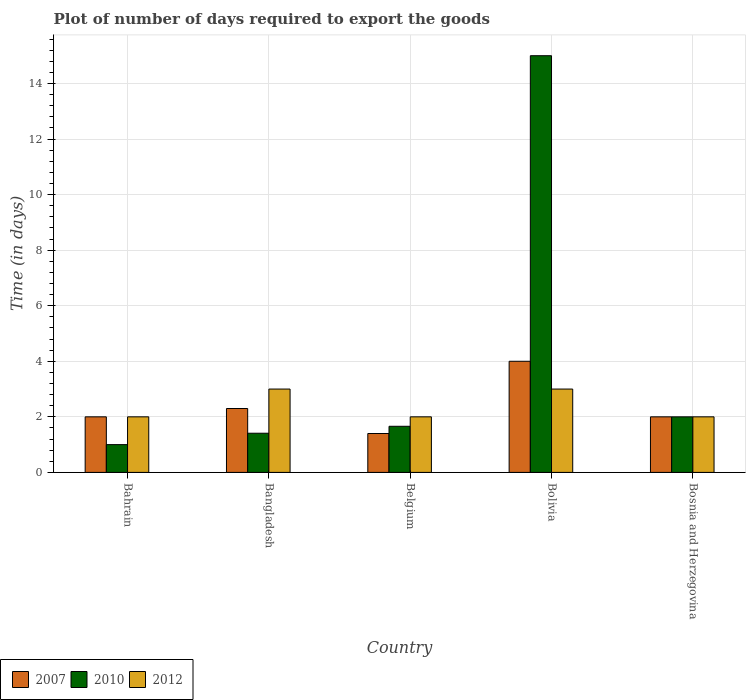How many different coloured bars are there?
Your answer should be compact. 3. How many groups of bars are there?
Your answer should be very brief. 5. Are the number of bars per tick equal to the number of legend labels?
Provide a short and direct response. Yes. Are the number of bars on each tick of the X-axis equal?
Offer a terse response. Yes. How many bars are there on the 4th tick from the right?
Give a very brief answer. 3. In how many cases, is the number of bars for a given country not equal to the number of legend labels?
Your response must be concise. 0. Across all countries, what is the minimum time required to export goods in 2010?
Ensure brevity in your answer.  1. In which country was the time required to export goods in 2012 maximum?
Your response must be concise. Bangladesh. In which country was the time required to export goods in 2010 minimum?
Make the answer very short. Bahrain. What is the total time required to export goods in 2010 in the graph?
Your answer should be compact. 21.07. What is the difference between the time required to export goods in 2012 in Bangladesh and the time required to export goods in 2010 in Bosnia and Herzegovina?
Offer a very short reply. 1. What is the average time required to export goods in 2007 per country?
Your answer should be very brief. 2.34. What is the difference between the time required to export goods of/in 2010 and time required to export goods of/in 2007 in Bangladesh?
Your answer should be compact. -0.89. In how many countries, is the time required to export goods in 2010 greater than 2.4 days?
Ensure brevity in your answer.  1. What is the ratio of the time required to export goods in 2010 in Belgium to that in Bosnia and Herzegovina?
Provide a succinct answer. 0.83. Is the time required to export goods in 2012 in Bahrain less than that in Bangladesh?
Provide a short and direct response. Yes. What is the difference between the highest and the second highest time required to export goods in 2007?
Offer a very short reply. 0.3. What is the difference between the highest and the lowest time required to export goods in 2012?
Make the answer very short. 1. In how many countries, is the time required to export goods in 2012 greater than the average time required to export goods in 2012 taken over all countries?
Your answer should be very brief. 2. Is the sum of the time required to export goods in 2007 in Bahrain and Bolivia greater than the maximum time required to export goods in 2010 across all countries?
Your answer should be compact. No. Are the values on the major ticks of Y-axis written in scientific E-notation?
Keep it short and to the point. No. Does the graph contain grids?
Keep it short and to the point. Yes. How are the legend labels stacked?
Offer a very short reply. Horizontal. What is the title of the graph?
Make the answer very short. Plot of number of days required to export the goods. What is the label or title of the Y-axis?
Give a very brief answer. Time (in days). What is the Time (in days) in 2010 in Bahrain?
Offer a terse response. 1. What is the Time (in days) of 2010 in Bangladesh?
Make the answer very short. 1.41. What is the Time (in days) in 2007 in Belgium?
Offer a very short reply. 1.4. What is the Time (in days) of 2010 in Belgium?
Offer a terse response. 1.66. What is the Time (in days) in 2010 in Bolivia?
Give a very brief answer. 15. What is the Time (in days) in 2007 in Bosnia and Herzegovina?
Give a very brief answer. 2. What is the Time (in days) of 2010 in Bosnia and Herzegovina?
Provide a short and direct response. 2. Across all countries, what is the maximum Time (in days) of 2007?
Keep it short and to the point. 4. What is the total Time (in days) in 2007 in the graph?
Your answer should be very brief. 11.7. What is the total Time (in days) in 2010 in the graph?
Your answer should be very brief. 21.07. What is the difference between the Time (in days) of 2007 in Bahrain and that in Bangladesh?
Ensure brevity in your answer.  -0.3. What is the difference between the Time (in days) in 2010 in Bahrain and that in Bangladesh?
Keep it short and to the point. -0.41. What is the difference between the Time (in days) of 2012 in Bahrain and that in Bangladesh?
Provide a succinct answer. -1. What is the difference between the Time (in days) of 2010 in Bahrain and that in Belgium?
Ensure brevity in your answer.  -0.66. What is the difference between the Time (in days) of 2007 in Bahrain and that in Bolivia?
Your answer should be compact. -2. What is the difference between the Time (in days) of 2010 in Bahrain and that in Bolivia?
Your answer should be very brief. -14. What is the difference between the Time (in days) of 2012 in Bahrain and that in Bolivia?
Keep it short and to the point. -1. What is the difference between the Time (in days) of 2007 in Bahrain and that in Bosnia and Herzegovina?
Keep it short and to the point. 0. What is the difference between the Time (in days) of 2010 in Bangladesh and that in Belgium?
Your answer should be very brief. -0.25. What is the difference between the Time (in days) of 2012 in Bangladesh and that in Belgium?
Make the answer very short. 1. What is the difference between the Time (in days) in 2007 in Bangladesh and that in Bolivia?
Your response must be concise. -1.7. What is the difference between the Time (in days) of 2010 in Bangladesh and that in Bolivia?
Your answer should be very brief. -13.59. What is the difference between the Time (in days) in 2010 in Bangladesh and that in Bosnia and Herzegovina?
Make the answer very short. -0.59. What is the difference between the Time (in days) in 2012 in Bangladesh and that in Bosnia and Herzegovina?
Offer a very short reply. 1. What is the difference between the Time (in days) in 2010 in Belgium and that in Bolivia?
Your answer should be very brief. -13.34. What is the difference between the Time (in days) in 2010 in Belgium and that in Bosnia and Herzegovina?
Provide a succinct answer. -0.34. What is the difference between the Time (in days) of 2007 in Bolivia and that in Bosnia and Herzegovina?
Provide a succinct answer. 2. What is the difference between the Time (in days) of 2007 in Bahrain and the Time (in days) of 2010 in Bangladesh?
Keep it short and to the point. 0.59. What is the difference between the Time (in days) in 2007 in Bahrain and the Time (in days) in 2012 in Bangladesh?
Ensure brevity in your answer.  -1. What is the difference between the Time (in days) of 2007 in Bahrain and the Time (in days) of 2010 in Belgium?
Ensure brevity in your answer.  0.34. What is the difference between the Time (in days) in 2010 in Bahrain and the Time (in days) in 2012 in Belgium?
Your answer should be very brief. -1. What is the difference between the Time (in days) of 2010 in Bahrain and the Time (in days) of 2012 in Bolivia?
Offer a very short reply. -2. What is the difference between the Time (in days) in 2007 in Bahrain and the Time (in days) in 2010 in Bosnia and Herzegovina?
Provide a succinct answer. 0. What is the difference between the Time (in days) of 2007 in Bangladesh and the Time (in days) of 2010 in Belgium?
Your answer should be very brief. 0.64. What is the difference between the Time (in days) in 2007 in Bangladesh and the Time (in days) in 2012 in Belgium?
Make the answer very short. 0.3. What is the difference between the Time (in days) of 2010 in Bangladesh and the Time (in days) of 2012 in Belgium?
Provide a short and direct response. -0.59. What is the difference between the Time (in days) of 2007 in Bangladesh and the Time (in days) of 2012 in Bolivia?
Ensure brevity in your answer.  -0.7. What is the difference between the Time (in days) in 2010 in Bangladesh and the Time (in days) in 2012 in Bolivia?
Offer a very short reply. -1.59. What is the difference between the Time (in days) of 2007 in Bangladesh and the Time (in days) of 2010 in Bosnia and Herzegovina?
Your answer should be compact. 0.3. What is the difference between the Time (in days) in 2010 in Bangladesh and the Time (in days) in 2012 in Bosnia and Herzegovina?
Offer a very short reply. -0.59. What is the difference between the Time (in days) of 2010 in Belgium and the Time (in days) of 2012 in Bolivia?
Offer a terse response. -1.34. What is the difference between the Time (in days) of 2007 in Belgium and the Time (in days) of 2010 in Bosnia and Herzegovina?
Provide a short and direct response. -0.6. What is the difference between the Time (in days) in 2010 in Belgium and the Time (in days) in 2012 in Bosnia and Herzegovina?
Your answer should be very brief. -0.34. What is the difference between the Time (in days) in 2010 in Bolivia and the Time (in days) in 2012 in Bosnia and Herzegovina?
Keep it short and to the point. 13. What is the average Time (in days) in 2007 per country?
Provide a short and direct response. 2.34. What is the average Time (in days) of 2010 per country?
Your response must be concise. 4.21. What is the average Time (in days) of 2012 per country?
Give a very brief answer. 2.4. What is the difference between the Time (in days) of 2007 and Time (in days) of 2012 in Bahrain?
Keep it short and to the point. 0. What is the difference between the Time (in days) in 2010 and Time (in days) in 2012 in Bahrain?
Give a very brief answer. -1. What is the difference between the Time (in days) of 2007 and Time (in days) of 2010 in Bangladesh?
Make the answer very short. 0.89. What is the difference between the Time (in days) of 2007 and Time (in days) of 2012 in Bangladesh?
Provide a succinct answer. -0.7. What is the difference between the Time (in days) in 2010 and Time (in days) in 2012 in Bangladesh?
Provide a succinct answer. -1.59. What is the difference between the Time (in days) in 2007 and Time (in days) in 2010 in Belgium?
Offer a very short reply. -0.26. What is the difference between the Time (in days) in 2007 and Time (in days) in 2012 in Belgium?
Ensure brevity in your answer.  -0.6. What is the difference between the Time (in days) of 2010 and Time (in days) of 2012 in Belgium?
Your answer should be very brief. -0.34. What is the difference between the Time (in days) of 2007 and Time (in days) of 2010 in Bolivia?
Your answer should be very brief. -11. What is the difference between the Time (in days) in 2007 and Time (in days) in 2012 in Bolivia?
Keep it short and to the point. 1. What is the difference between the Time (in days) in 2007 and Time (in days) in 2012 in Bosnia and Herzegovina?
Make the answer very short. 0. What is the difference between the Time (in days) of 2010 and Time (in days) of 2012 in Bosnia and Herzegovina?
Give a very brief answer. 0. What is the ratio of the Time (in days) in 2007 in Bahrain to that in Bangladesh?
Your answer should be compact. 0.87. What is the ratio of the Time (in days) in 2010 in Bahrain to that in Bangladesh?
Your answer should be very brief. 0.71. What is the ratio of the Time (in days) of 2007 in Bahrain to that in Belgium?
Your answer should be very brief. 1.43. What is the ratio of the Time (in days) in 2010 in Bahrain to that in Belgium?
Provide a short and direct response. 0.6. What is the ratio of the Time (in days) of 2012 in Bahrain to that in Belgium?
Offer a very short reply. 1. What is the ratio of the Time (in days) of 2010 in Bahrain to that in Bolivia?
Offer a terse response. 0.07. What is the ratio of the Time (in days) of 2012 in Bahrain to that in Bolivia?
Give a very brief answer. 0.67. What is the ratio of the Time (in days) in 2007 in Bangladesh to that in Belgium?
Ensure brevity in your answer.  1.64. What is the ratio of the Time (in days) in 2010 in Bangladesh to that in Belgium?
Keep it short and to the point. 0.85. What is the ratio of the Time (in days) of 2012 in Bangladesh to that in Belgium?
Make the answer very short. 1.5. What is the ratio of the Time (in days) in 2007 in Bangladesh to that in Bolivia?
Provide a succinct answer. 0.57. What is the ratio of the Time (in days) of 2010 in Bangladesh to that in Bolivia?
Offer a very short reply. 0.09. What is the ratio of the Time (in days) in 2012 in Bangladesh to that in Bolivia?
Your answer should be compact. 1. What is the ratio of the Time (in days) of 2007 in Bangladesh to that in Bosnia and Herzegovina?
Your response must be concise. 1.15. What is the ratio of the Time (in days) of 2010 in Bangladesh to that in Bosnia and Herzegovina?
Your response must be concise. 0.7. What is the ratio of the Time (in days) of 2012 in Bangladesh to that in Bosnia and Herzegovina?
Your answer should be compact. 1.5. What is the ratio of the Time (in days) in 2007 in Belgium to that in Bolivia?
Make the answer very short. 0.35. What is the ratio of the Time (in days) of 2010 in Belgium to that in Bolivia?
Keep it short and to the point. 0.11. What is the ratio of the Time (in days) of 2012 in Belgium to that in Bolivia?
Offer a terse response. 0.67. What is the ratio of the Time (in days) of 2007 in Belgium to that in Bosnia and Herzegovina?
Your answer should be very brief. 0.7. What is the ratio of the Time (in days) in 2010 in Belgium to that in Bosnia and Herzegovina?
Provide a short and direct response. 0.83. What is the ratio of the Time (in days) in 2010 in Bolivia to that in Bosnia and Herzegovina?
Ensure brevity in your answer.  7.5. What is the ratio of the Time (in days) in 2012 in Bolivia to that in Bosnia and Herzegovina?
Your response must be concise. 1.5. What is the difference between the highest and the second highest Time (in days) of 2012?
Offer a very short reply. 0. What is the difference between the highest and the lowest Time (in days) of 2007?
Give a very brief answer. 2.6. What is the difference between the highest and the lowest Time (in days) of 2010?
Ensure brevity in your answer.  14. What is the difference between the highest and the lowest Time (in days) in 2012?
Offer a terse response. 1. 